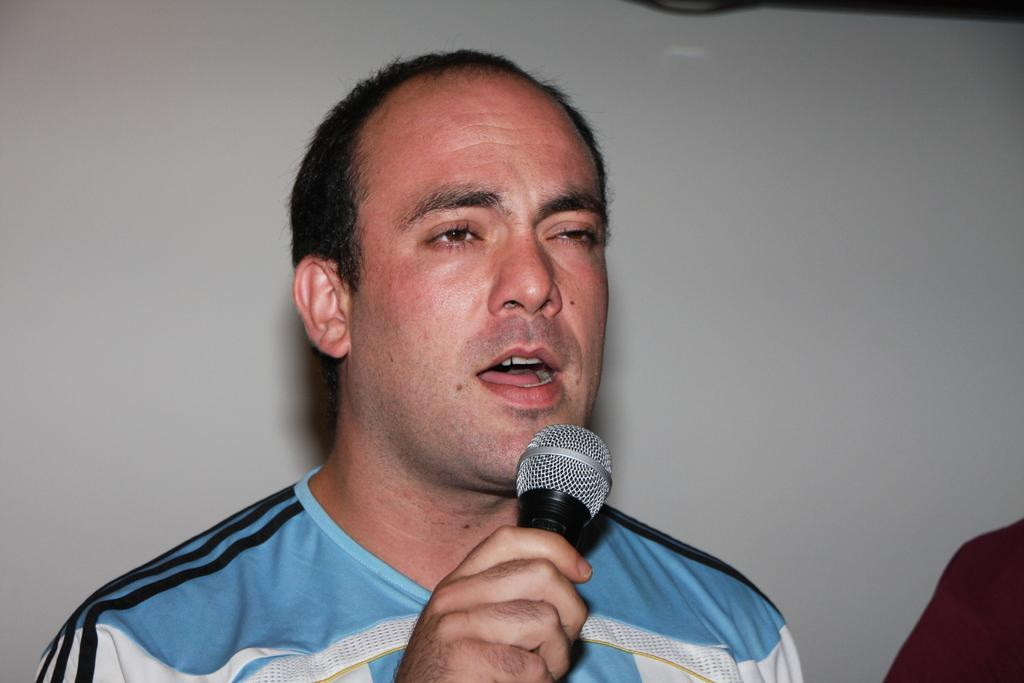What is the person in the image doing? The person is standing in the image and holding a microphone. What can be seen in the background of the image? There is a wall in the background of the image. What type of print is visible on the wall in the image? There is no print visible on the wall in the image; only the wall itself is mentioned. 